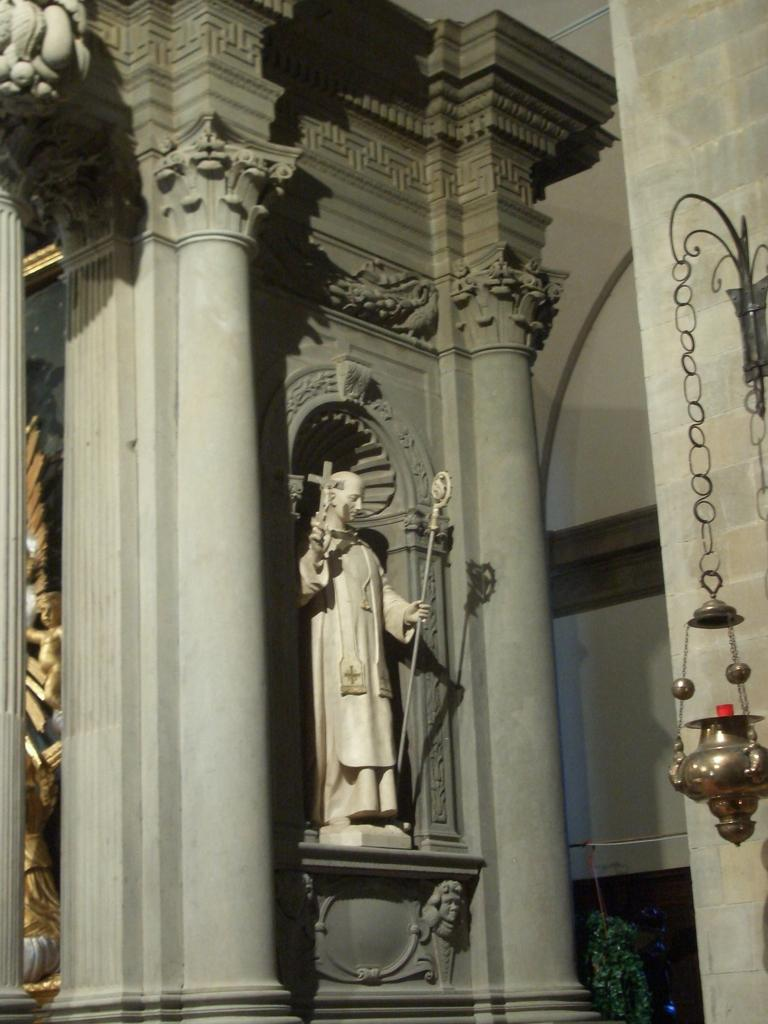What is the main subject in the image? There is a statue in the image. What other objects can be seen in the image? There is a lamp, hooks, and pillars visible in the image. What type of jam is being stored in the box next to the statue in the image? There is no box or jam present in the image. What type of plough is being used to maintain the area around the statue in the image? There is no plough present in the image. 